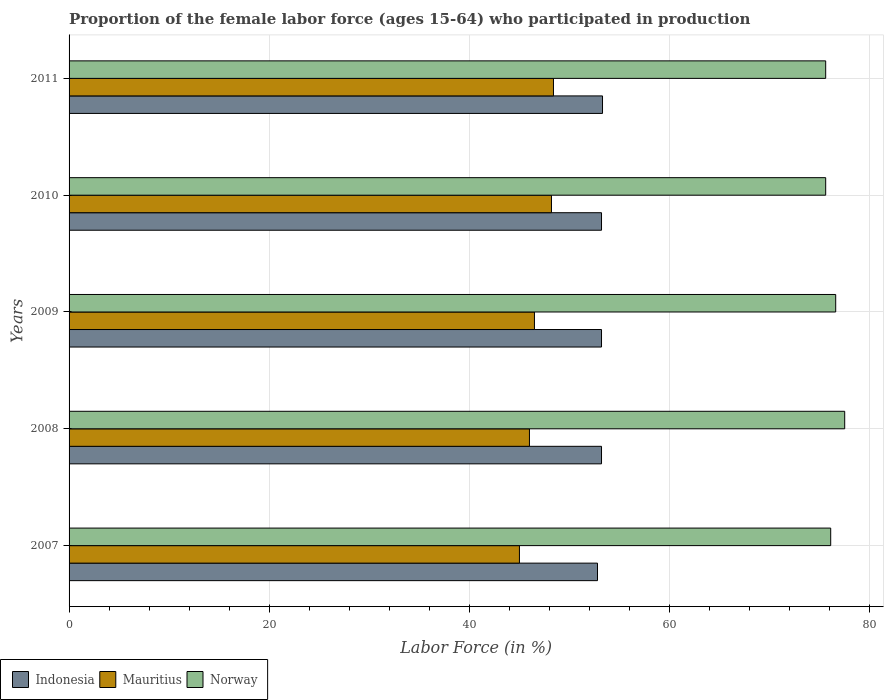How many different coloured bars are there?
Your answer should be compact. 3. Are the number of bars on each tick of the Y-axis equal?
Ensure brevity in your answer.  Yes. How many bars are there on the 3rd tick from the top?
Your response must be concise. 3. How many bars are there on the 2nd tick from the bottom?
Provide a succinct answer. 3. What is the proportion of the female labor force who participated in production in Indonesia in 2009?
Give a very brief answer. 53.2. Across all years, what is the maximum proportion of the female labor force who participated in production in Mauritius?
Provide a short and direct response. 48.4. Across all years, what is the minimum proportion of the female labor force who participated in production in Mauritius?
Ensure brevity in your answer.  45. What is the total proportion of the female labor force who participated in production in Mauritius in the graph?
Your answer should be very brief. 234.1. What is the difference between the proportion of the female labor force who participated in production in Mauritius in 2007 and that in 2010?
Your response must be concise. -3.2. What is the difference between the proportion of the female labor force who participated in production in Norway in 2010 and the proportion of the female labor force who participated in production in Indonesia in 2008?
Provide a short and direct response. 22.4. What is the average proportion of the female labor force who participated in production in Indonesia per year?
Your answer should be very brief. 53.14. In the year 2009, what is the difference between the proportion of the female labor force who participated in production in Norway and proportion of the female labor force who participated in production in Indonesia?
Provide a succinct answer. 23.4. In how many years, is the proportion of the female labor force who participated in production in Indonesia greater than 64 %?
Provide a short and direct response. 0. What is the ratio of the proportion of the female labor force who participated in production in Mauritius in 2008 to that in 2011?
Give a very brief answer. 0.95. Is the difference between the proportion of the female labor force who participated in production in Norway in 2007 and 2008 greater than the difference between the proportion of the female labor force who participated in production in Indonesia in 2007 and 2008?
Offer a terse response. No. What is the difference between the highest and the second highest proportion of the female labor force who participated in production in Norway?
Ensure brevity in your answer.  0.9. In how many years, is the proportion of the female labor force who participated in production in Norway greater than the average proportion of the female labor force who participated in production in Norway taken over all years?
Ensure brevity in your answer.  2. Is the sum of the proportion of the female labor force who participated in production in Mauritius in 2008 and 2009 greater than the maximum proportion of the female labor force who participated in production in Norway across all years?
Offer a terse response. Yes. What does the 1st bar from the top in 2008 represents?
Offer a very short reply. Norway. What does the 2nd bar from the bottom in 2009 represents?
Offer a very short reply. Mauritius. Is it the case that in every year, the sum of the proportion of the female labor force who participated in production in Mauritius and proportion of the female labor force who participated in production in Norway is greater than the proportion of the female labor force who participated in production in Indonesia?
Provide a short and direct response. Yes. Are all the bars in the graph horizontal?
Make the answer very short. Yes. What is the difference between two consecutive major ticks on the X-axis?
Provide a short and direct response. 20. Does the graph contain grids?
Your response must be concise. Yes. Where does the legend appear in the graph?
Keep it short and to the point. Bottom left. What is the title of the graph?
Offer a very short reply. Proportion of the female labor force (ages 15-64) who participated in production. What is the label or title of the X-axis?
Your response must be concise. Labor Force (in %). What is the label or title of the Y-axis?
Provide a succinct answer. Years. What is the Labor Force (in %) in Indonesia in 2007?
Provide a short and direct response. 52.8. What is the Labor Force (in %) of Mauritius in 2007?
Ensure brevity in your answer.  45. What is the Labor Force (in %) of Norway in 2007?
Make the answer very short. 76.1. What is the Labor Force (in %) in Indonesia in 2008?
Your answer should be compact. 53.2. What is the Labor Force (in %) of Norway in 2008?
Provide a succinct answer. 77.5. What is the Labor Force (in %) in Indonesia in 2009?
Provide a short and direct response. 53.2. What is the Labor Force (in %) of Mauritius in 2009?
Your answer should be very brief. 46.5. What is the Labor Force (in %) in Norway in 2009?
Your response must be concise. 76.6. What is the Labor Force (in %) of Indonesia in 2010?
Offer a terse response. 53.2. What is the Labor Force (in %) in Mauritius in 2010?
Your answer should be compact. 48.2. What is the Labor Force (in %) in Norway in 2010?
Your answer should be compact. 75.6. What is the Labor Force (in %) in Indonesia in 2011?
Your answer should be very brief. 53.3. What is the Labor Force (in %) of Mauritius in 2011?
Your response must be concise. 48.4. What is the Labor Force (in %) in Norway in 2011?
Provide a short and direct response. 75.6. Across all years, what is the maximum Labor Force (in %) in Indonesia?
Give a very brief answer. 53.3. Across all years, what is the maximum Labor Force (in %) in Mauritius?
Your response must be concise. 48.4. Across all years, what is the maximum Labor Force (in %) in Norway?
Make the answer very short. 77.5. Across all years, what is the minimum Labor Force (in %) of Indonesia?
Your answer should be very brief. 52.8. Across all years, what is the minimum Labor Force (in %) of Norway?
Offer a terse response. 75.6. What is the total Labor Force (in %) in Indonesia in the graph?
Provide a succinct answer. 265.7. What is the total Labor Force (in %) in Mauritius in the graph?
Offer a terse response. 234.1. What is the total Labor Force (in %) of Norway in the graph?
Offer a very short reply. 381.4. What is the difference between the Labor Force (in %) of Indonesia in 2007 and that in 2008?
Ensure brevity in your answer.  -0.4. What is the difference between the Labor Force (in %) in Mauritius in 2007 and that in 2008?
Your response must be concise. -1. What is the difference between the Labor Force (in %) in Norway in 2007 and that in 2009?
Provide a succinct answer. -0.5. What is the difference between the Labor Force (in %) in Indonesia in 2007 and that in 2010?
Keep it short and to the point. -0.4. What is the difference between the Labor Force (in %) of Mauritius in 2007 and that in 2010?
Offer a very short reply. -3.2. What is the difference between the Labor Force (in %) in Mauritius in 2007 and that in 2011?
Your answer should be compact. -3.4. What is the difference between the Labor Force (in %) of Norway in 2007 and that in 2011?
Give a very brief answer. 0.5. What is the difference between the Labor Force (in %) in Mauritius in 2008 and that in 2009?
Ensure brevity in your answer.  -0.5. What is the difference between the Labor Force (in %) of Indonesia in 2008 and that in 2011?
Your response must be concise. -0.1. What is the difference between the Labor Force (in %) of Mauritius in 2008 and that in 2011?
Give a very brief answer. -2.4. What is the difference between the Labor Force (in %) in Norway in 2008 and that in 2011?
Your response must be concise. 1.9. What is the difference between the Labor Force (in %) of Norway in 2009 and that in 2010?
Offer a very short reply. 1. What is the difference between the Labor Force (in %) in Indonesia in 2010 and that in 2011?
Ensure brevity in your answer.  -0.1. What is the difference between the Labor Force (in %) in Indonesia in 2007 and the Labor Force (in %) in Mauritius in 2008?
Give a very brief answer. 6.8. What is the difference between the Labor Force (in %) in Indonesia in 2007 and the Labor Force (in %) in Norway in 2008?
Provide a short and direct response. -24.7. What is the difference between the Labor Force (in %) of Mauritius in 2007 and the Labor Force (in %) of Norway in 2008?
Your response must be concise. -32.5. What is the difference between the Labor Force (in %) in Indonesia in 2007 and the Labor Force (in %) in Mauritius in 2009?
Offer a very short reply. 6.3. What is the difference between the Labor Force (in %) of Indonesia in 2007 and the Labor Force (in %) of Norway in 2009?
Offer a terse response. -23.8. What is the difference between the Labor Force (in %) in Mauritius in 2007 and the Labor Force (in %) in Norway in 2009?
Provide a succinct answer. -31.6. What is the difference between the Labor Force (in %) in Indonesia in 2007 and the Labor Force (in %) in Mauritius in 2010?
Your answer should be compact. 4.6. What is the difference between the Labor Force (in %) in Indonesia in 2007 and the Labor Force (in %) in Norway in 2010?
Ensure brevity in your answer.  -22.8. What is the difference between the Labor Force (in %) of Mauritius in 2007 and the Labor Force (in %) of Norway in 2010?
Your answer should be very brief. -30.6. What is the difference between the Labor Force (in %) of Indonesia in 2007 and the Labor Force (in %) of Mauritius in 2011?
Ensure brevity in your answer.  4.4. What is the difference between the Labor Force (in %) in Indonesia in 2007 and the Labor Force (in %) in Norway in 2011?
Offer a very short reply. -22.8. What is the difference between the Labor Force (in %) in Mauritius in 2007 and the Labor Force (in %) in Norway in 2011?
Provide a succinct answer. -30.6. What is the difference between the Labor Force (in %) in Indonesia in 2008 and the Labor Force (in %) in Norway in 2009?
Make the answer very short. -23.4. What is the difference between the Labor Force (in %) in Mauritius in 2008 and the Labor Force (in %) in Norway in 2009?
Keep it short and to the point. -30.6. What is the difference between the Labor Force (in %) in Indonesia in 2008 and the Labor Force (in %) in Mauritius in 2010?
Your response must be concise. 5. What is the difference between the Labor Force (in %) of Indonesia in 2008 and the Labor Force (in %) of Norway in 2010?
Your response must be concise. -22.4. What is the difference between the Labor Force (in %) in Mauritius in 2008 and the Labor Force (in %) in Norway in 2010?
Your answer should be very brief. -29.6. What is the difference between the Labor Force (in %) in Indonesia in 2008 and the Labor Force (in %) in Norway in 2011?
Your answer should be compact. -22.4. What is the difference between the Labor Force (in %) of Mauritius in 2008 and the Labor Force (in %) of Norway in 2011?
Keep it short and to the point. -29.6. What is the difference between the Labor Force (in %) in Indonesia in 2009 and the Labor Force (in %) in Mauritius in 2010?
Your response must be concise. 5. What is the difference between the Labor Force (in %) in Indonesia in 2009 and the Labor Force (in %) in Norway in 2010?
Give a very brief answer. -22.4. What is the difference between the Labor Force (in %) in Mauritius in 2009 and the Labor Force (in %) in Norway in 2010?
Keep it short and to the point. -29.1. What is the difference between the Labor Force (in %) of Indonesia in 2009 and the Labor Force (in %) of Mauritius in 2011?
Ensure brevity in your answer.  4.8. What is the difference between the Labor Force (in %) of Indonesia in 2009 and the Labor Force (in %) of Norway in 2011?
Offer a terse response. -22.4. What is the difference between the Labor Force (in %) of Mauritius in 2009 and the Labor Force (in %) of Norway in 2011?
Your answer should be compact. -29.1. What is the difference between the Labor Force (in %) in Indonesia in 2010 and the Labor Force (in %) in Mauritius in 2011?
Ensure brevity in your answer.  4.8. What is the difference between the Labor Force (in %) in Indonesia in 2010 and the Labor Force (in %) in Norway in 2011?
Give a very brief answer. -22.4. What is the difference between the Labor Force (in %) in Mauritius in 2010 and the Labor Force (in %) in Norway in 2011?
Your response must be concise. -27.4. What is the average Labor Force (in %) in Indonesia per year?
Keep it short and to the point. 53.14. What is the average Labor Force (in %) of Mauritius per year?
Your answer should be compact. 46.82. What is the average Labor Force (in %) in Norway per year?
Offer a very short reply. 76.28. In the year 2007, what is the difference between the Labor Force (in %) in Indonesia and Labor Force (in %) in Norway?
Make the answer very short. -23.3. In the year 2007, what is the difference between the Labor Force (in %) in Mauritius and Labor Force (in %) in Norway?
Your answer should be very brief. -31.1. In the year 2008, what is the difference between the Labor Force (in %) of Indonesia and Labor Force (in %) of Mauritius?
Keep it short and to the point. 7.2. In the year 2008, what is the difference between the Labor Force (in %) in Indonesia and Labor Force (in %) in Norway?
Make the answer very short. -24.3. In the year 2008, what is the difference between the Labor Force (in %) in Mauritius and Labor Force (in %) in Norway?
Ensure brevity in your answer.  -31.5. In the year 2009, what is the difference between the Labor Force (in %) of Indonesia and Labor Force (in %) of Norway?
Give a very brief answer. -23.4. In the year 2009, what is the difference between the Labor Force (in %) in Mauritius and Labor Force (in %) in Norway?
Make the answer very short. -30.1. In the year 2010, what is the difference between the Labor Force (in %) of Indonesia and Labor Force (in %) of Mauritius?
Ensure brevity in your answer.  5. In the year 2010, what is the difference between the Labor Force (in %) of Indonesia and Labor Force (in %) of Norway?
Offer a very short reply. -22.4. In the year 2010, what is the difference between the Labor Force (in %) of Mauritius and Labor Force (in %) of Norway?
Offer a terse response. -27.4. In the year 2011, what is the difference between the Labor Force (in %) in Indonesia and Labor Force (in %) in Norway?
Provide a succinct answer. -22.3. In the year 2011, what is the difference between the Labor Force (in %) in Mauritius and Labor Force (in %) in Norway?
Your answer should be compact. -27.2. What is the ratio of the Labor Force (in %) in Mauritius in 2007 to that in 2008?
Provide a short and direct response. 0.98. What is the ratio of the Labor Force (in %) in Norway in 2007 to that in 2008?
Offer a terse response. 0.98. What is the ratio of the Labor Force (in %) in Indonesia in 2007 to that in 2009?
Make the answer very short. 0.99. What is the ratio of the Labor Force (in %) in Indonesia in 2007 to that in 2010?
Keep it short and to the point. 0.99. What is the ratio of the Labor Force (in %) in Mauritius in 2007 to that in 2010?
Offer a terse response. 0.93. What is the ratio of the Labor Force (in %) in Norway in 2007 to that in 2010?
Make the answer very short. 1.01. What is the ratio of the Labor Force (in %) in Indonesia in 2007 to that in 2011?
Your answer should be compact. 0.99. What is the ratio of the Labor Force (in %) of Mauritius in 2007 to that in 2011?
Keep it short and to the point. 0.93. What is the ratio of the Labor Force (in %) in Norway in 2007 to that in 2011?
Your answer should be very brief. 1.01. What is the ratio of the Labor Force (in %) of Norway in 2008 to that in 2009?
Offer a terse response. 1.01. What is the ratio of the Labor Force (in %) in Indonesia in 2008 to that in 2010?
Offer a terse response. 1. What is the ratio of the Labor Force (in %) in Mauritius in 2008 to that in 2010?
Your response must be concise. 0.95. What is the ratio of the Labor Force (in %) of Norway in 2008 to that in 2010?
Your response must be concise. 1.03. What is the ratio of the Labor Force (in %) of Mauritius in 2008 to that in 2011?
Give a very brief answer. 0.95. What is the ratio of the Labor Force (in %) of Norway in 2008 to that in 2011?
Your answer should be compact. 1.03. What is the ratio of the Labor Force (in %) in Mauritius in 2009 to that in 2010?
Keep it short and to the point. 0.96. What is the ratio of the Labor Force (in %) of Norway in 2009 to that in 2010?
Keep it short and to the point. 1.01. What is the ratio of the Labor Force (in %) in Mauritius in 2009 to that in 2011?
Give a very brief answer. 0.96. What is the ratio of the Labor Force (in %) of Norway in 2009 to that in 2011?
Your answer should be very brief. 1.01. What is the ratio of the Labor Force (in %) in Norway in 2010 to that in 2011?
Offer a terse response. 1. What is the difference between the highest and the second highest Labor Force (in %) of Mauritius?
Give a very brief answer. 0.2. What is the difference between the highest and the lowest Labor Force (in %) of Indonesia?
Your answer should be compact. 0.5. What is the difference between the highest and the lowest Labor Force (in %) in Mauritius?
Provide a short and direct response. 3.4. 